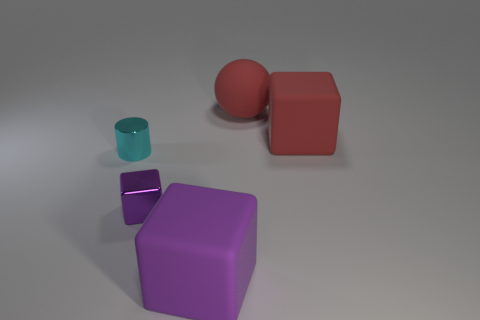Subtract all cyan balls. Subtract all cyan cylinders. How many balls are left? 1 Add 4 metal blocks. How many objects exist? 9 Subtract all balls. How many objects are left? 4 Subtract 0 blue cylinders. How many objects are left? 5 Subtract all tiny cubes. Subtract all small cylinders. How many objects are left? 3 Add 5 small blocks. How many small blocks are left? 6 Add 5 tiny purple cubes. How many tiny purple cubes exist? 6 